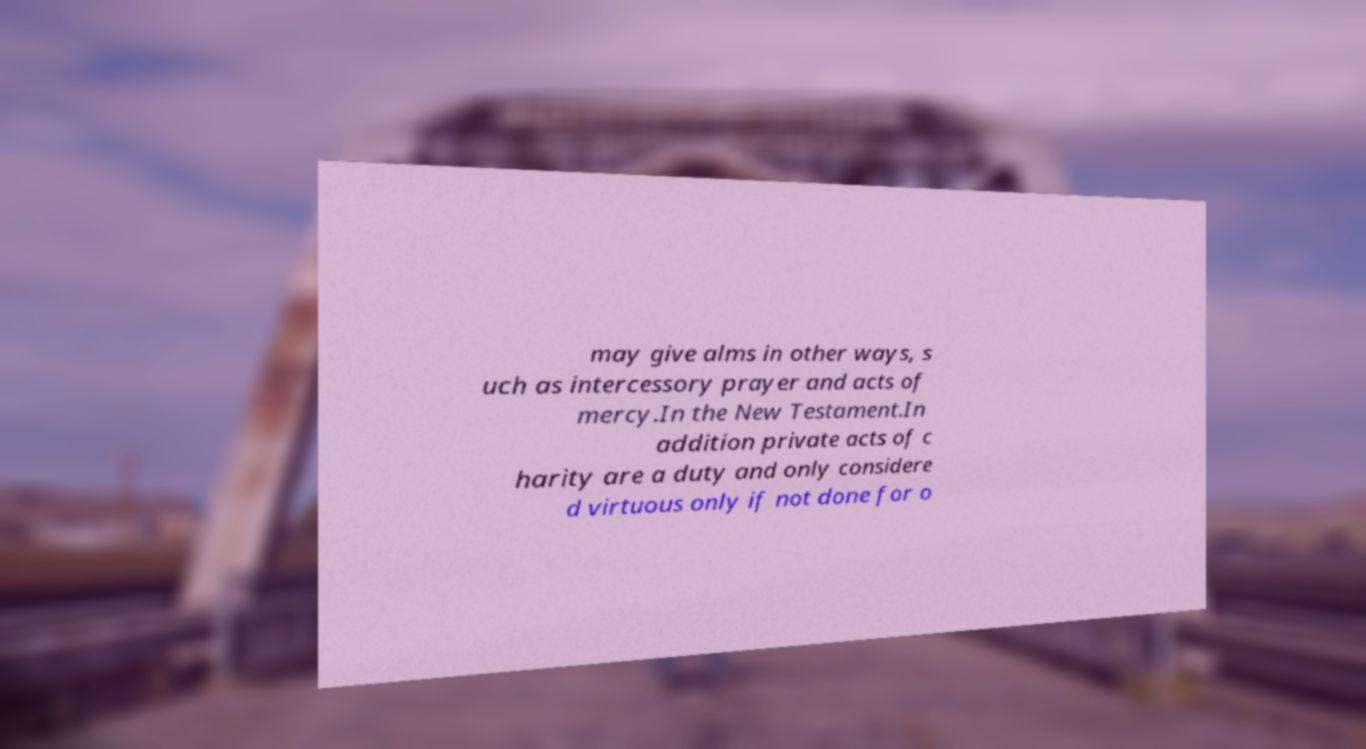Can you accurately transcribe the text from the provided image for me? may give alms in other ways, s uch as intercessory prayer and acts of mercy.In the New Testament.In addition private acts of c harity are a duty and only considere d virtuous only if not done for o 